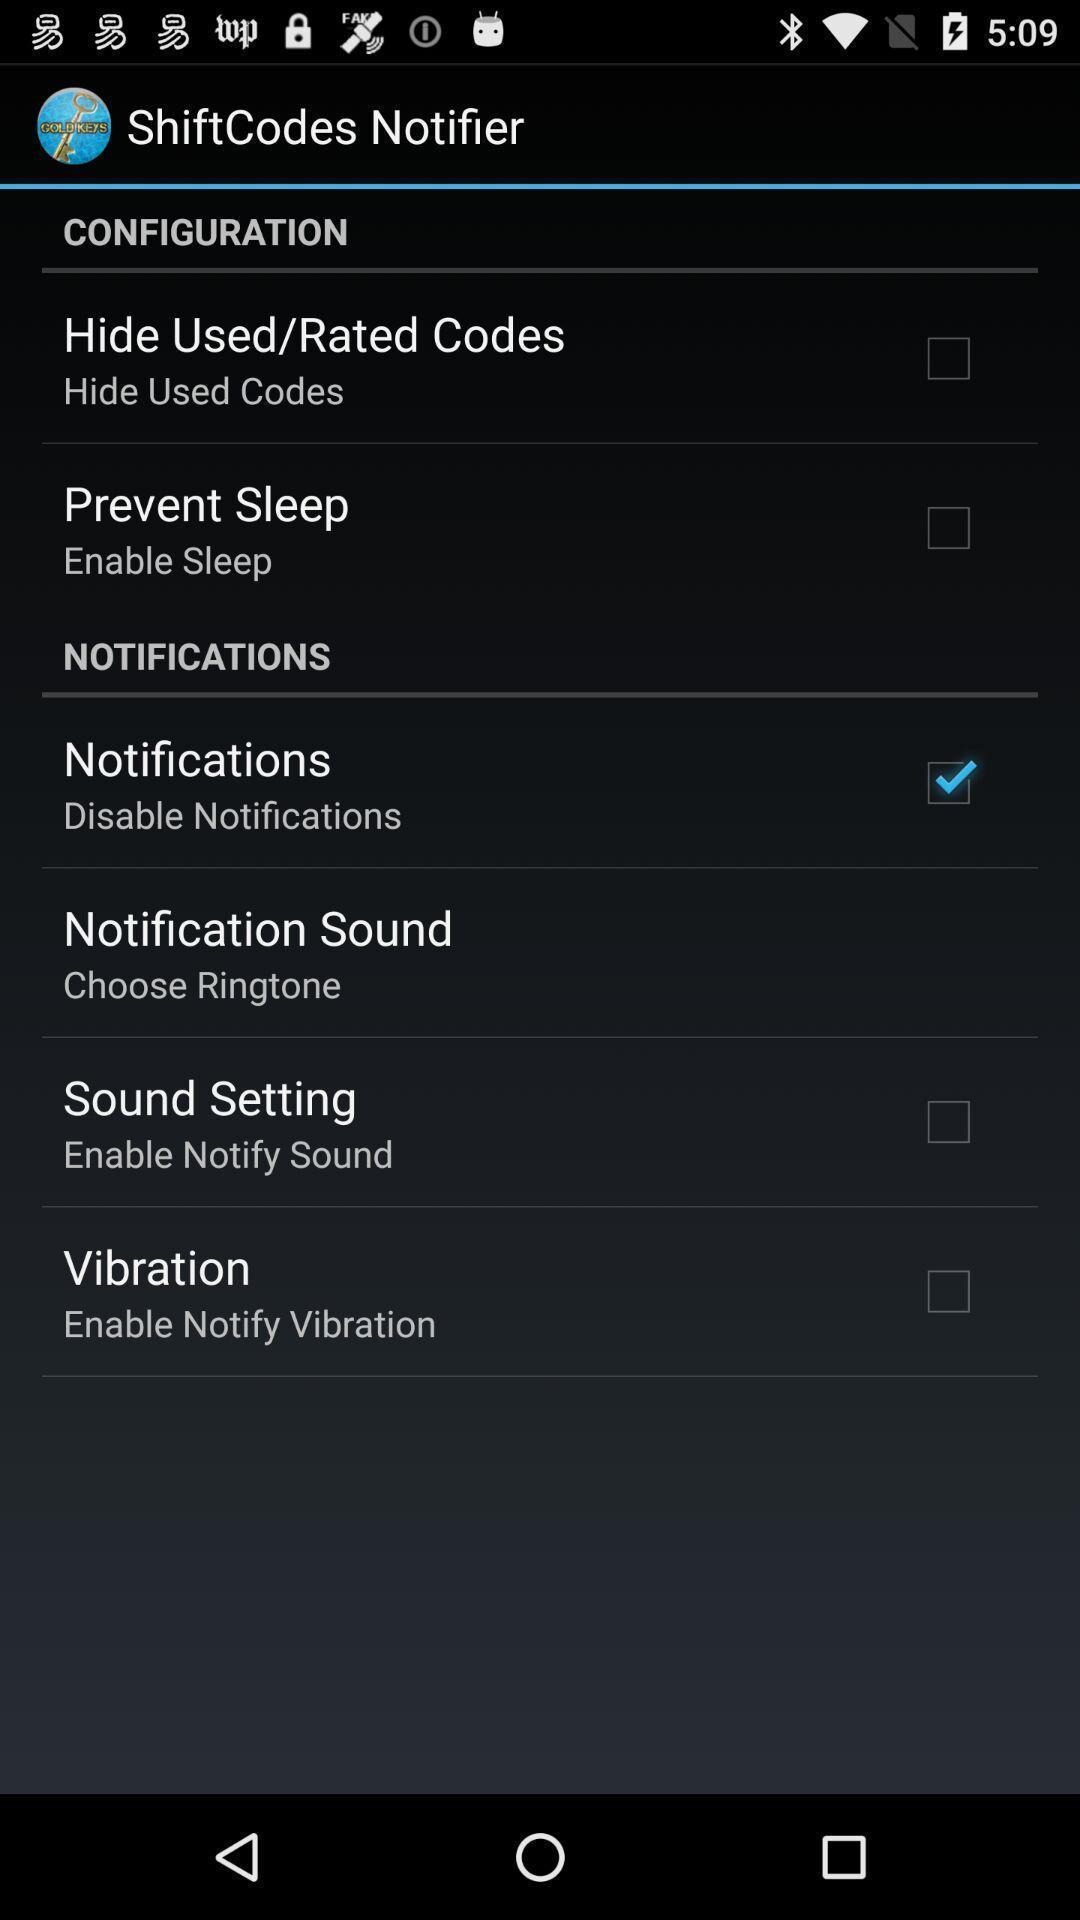What details can you identify in this image? Settings page with different options. 